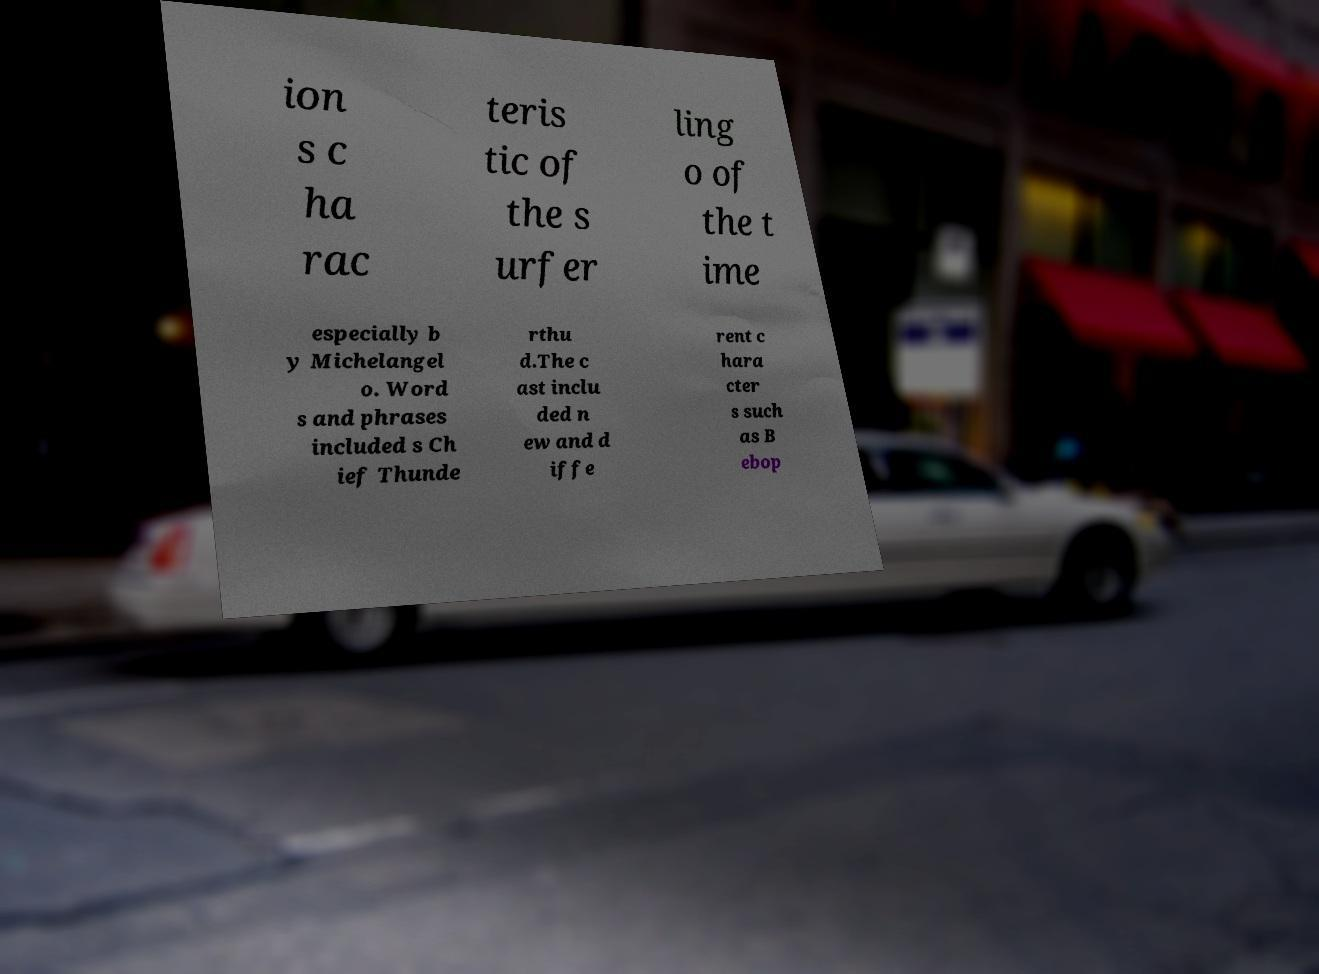Please read and relay the text visible in this image. What does it say? ion s c ha rac teris tic of the s urfer ling o of the t ime especially b y Michelangel o. Word s and phrases included s Ch ief Thunde rthu d.The c ast inclu ded n ew and d iffe rent c hara cter s such as B ebop 